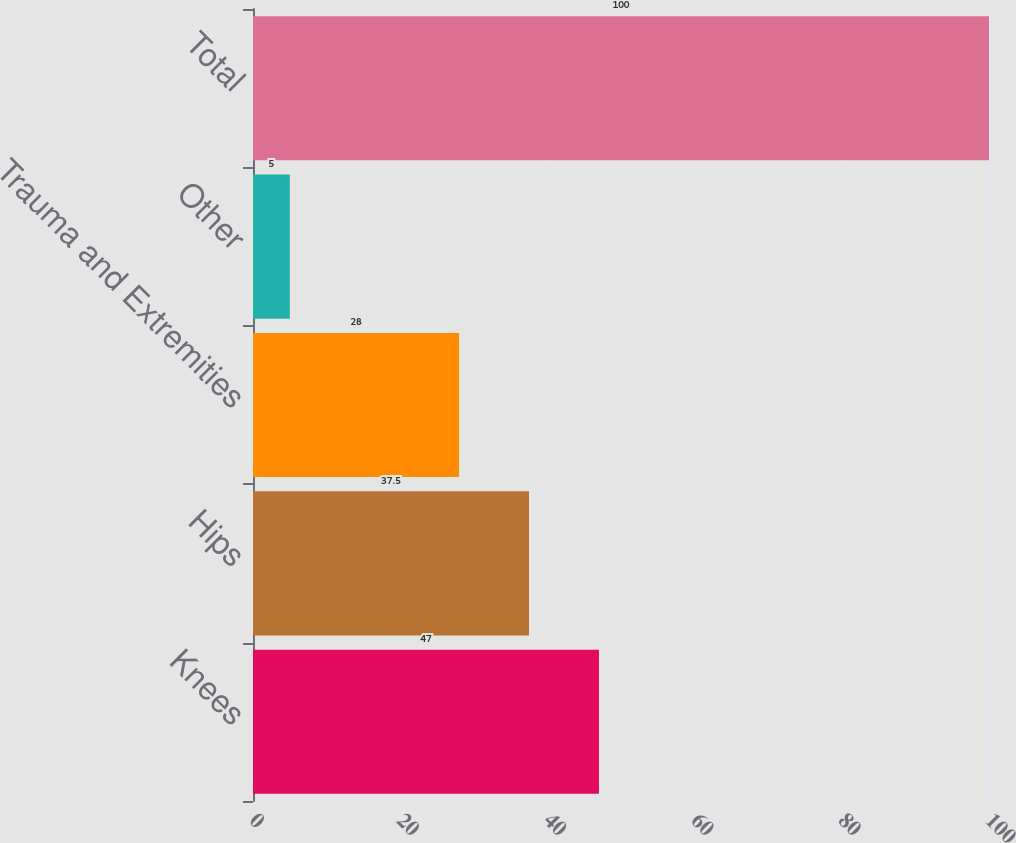<chart> <loc_0><loc_0><loc_500><loc_500><bar_chart><fcel>Knees<fcel>Hips<fcel>Trauma and Extremities<fcel>Other<fcel>Total<nl><fcel>47<fcel>37.5<fcel>28<fcel>5<fcel>100<nl></chart> 